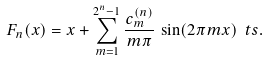Convert formula to latex. <formula><loc_0><loc_0><loc_500><loc_500>F _ { n } ( x ) = x + \sum _ { m = 1 } ^ { 2 ^ { n } - 1 } \frac { c ^ { ( n ) } _ { m } } { m \pi } \, \sin ( 2 \pi m x ) \ t s .</formula> 